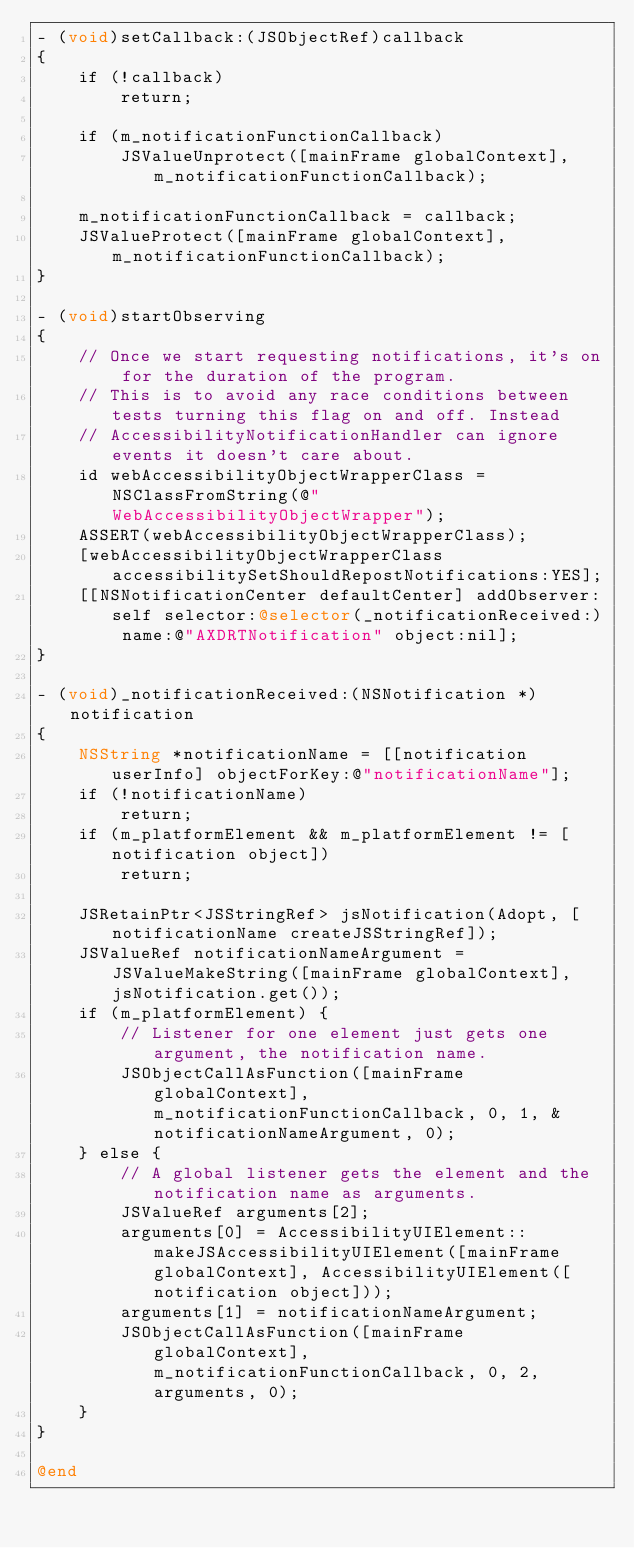<code> <loc_0><loc_0><loc_500><loc_500><_ObjectiveC_>- (void)setCallback:(JSObjectRef)callback
{
    if (!callback)
        return;
 
    if (m_notificationFunctionCallback) 
        JSValueUnprotect([mainFrame globalContext], m_notificationFunctionCallback);
    
    m_notificationFunctionCallback = callback;
    JSValueProtect([mainFrame globalContext], m_notificationFunctionCallback);
}

- (void)startObserving
{
    // Once we start requesting notifications, it's on for the duration of the program.
    // This is to avoid any race conditions between tests turning this flag on and off. Instead
    // AccessibilityNotificationHandler can ignore events it doesn't care about.
    id webAccessibilityObjectWrapperClass = NSClassFromString(@"WebAccessibilityObjectWrapper");
    ASSERT(webAccessibilityObjectWrapperClass);
    [webAccessibilityObjectWrapperClass accessibilitySetShouldRepostNotifications:YES];
    [[NSNotificationCenter defaultCenter] addObserver:self selector:@selector(_notificationReceived:) name:@"AXDRTNotification" object:nil];
}

- (void)_notificationReceived:(NSNotification *)notification
{
    NSString *notificationName = [[notification userInfo] objectForKey:@"notificationName"];
    if (!notificationName)
        return;
    if (m_platformElement && m_platformElement != [notification object])
        return;

    JSRetainPtr<JSStringRef> jsNotification(Adopt, [notificationName createJSStringRef]);
    JSValueRef notificationNameArgument = JSValueMakeString([mainFrame globalContext], jsNotification.get());
    if (m_platformElement) {
        // Listener for one element just gets one argument, the notification name.
        JSObjectCallAsFunction([mainFrame globalContext], m_notificationFunctionCallback, 0, 1, &notificationNameArgument, 0);
    } else {
        // A global listener gets the element and the notification name as arguments.
        JSValueRef arguments[2];
        arguments[0] = AccessibilityUIElement::makeJSAccessibilityUIElement([mainFrame globalContext], AccessibilityUIElement([notification object]));
        arguments[1] = notificationNameArgument;
        JSObjectCallAsFunction([mainFrame globalContext], m_notificationFunctionCallback, 0, 2, arguments, 0);
    }
}

@end

</code> 